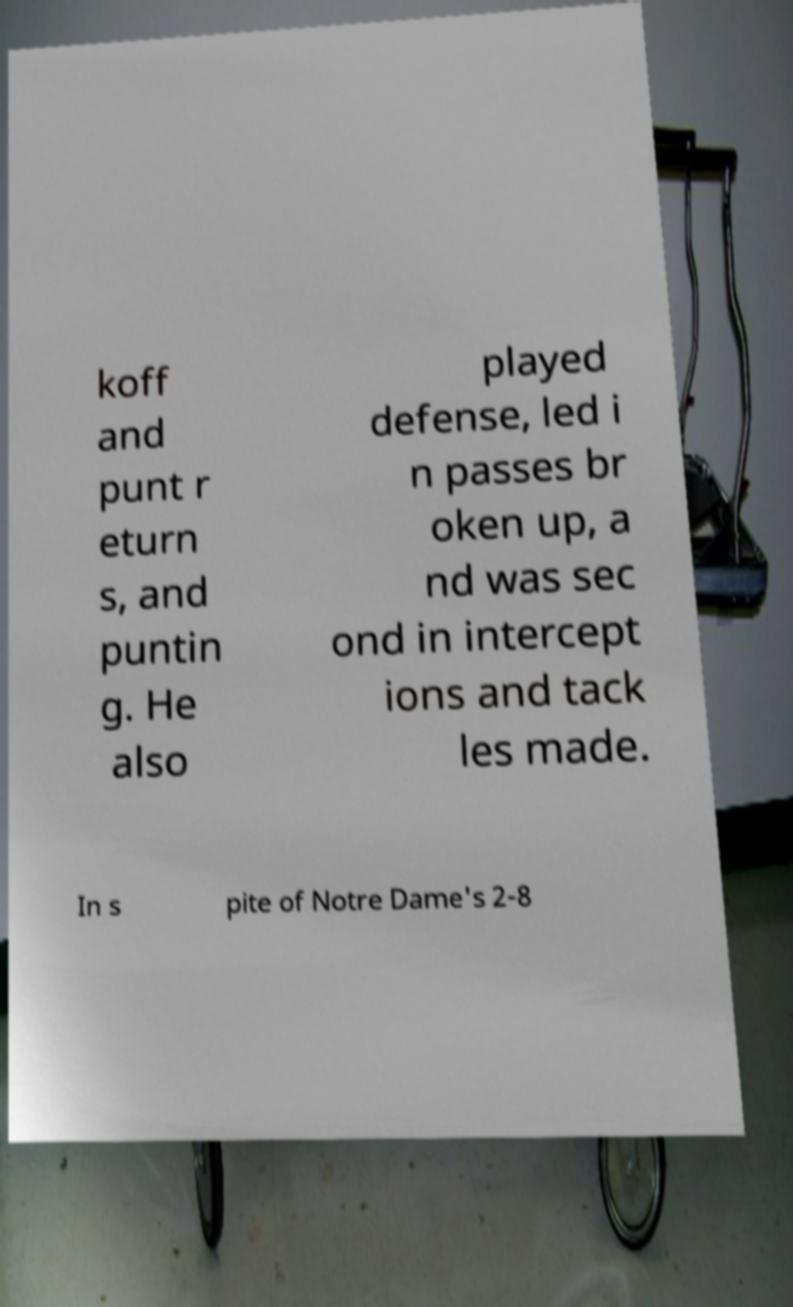Can you accurately transcribe the text from the provided image for me? koff and punt r eturn s, and puntin g. He also played defense, led i n passes br oken up, a nd was sec ond in intercept ions and tack les made. In s pite of Notre Dame's 2-8 